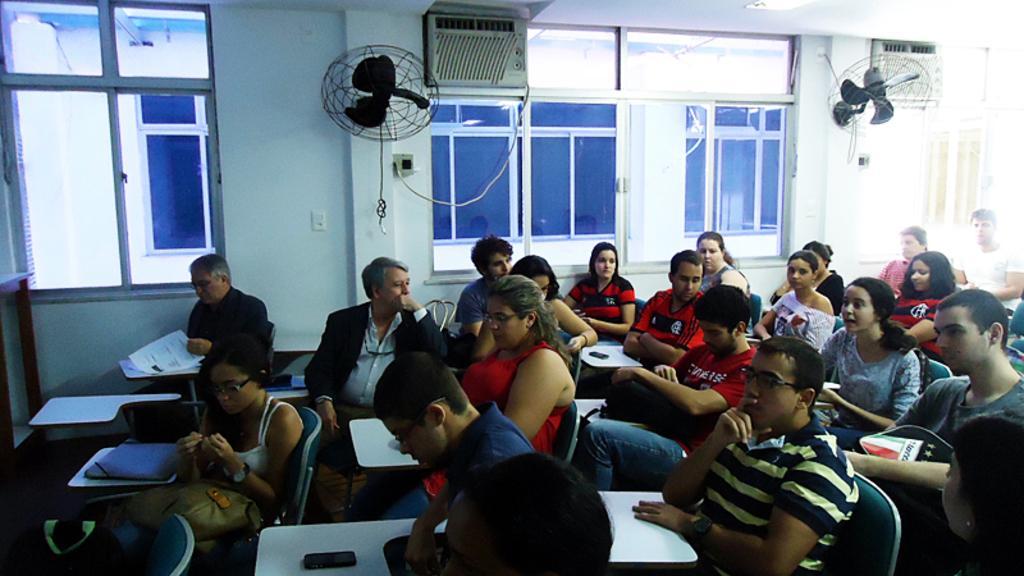Could you give a brief overview of what you see in this image? In this image in the center there are some people who are sitting on chairs, and there are some desks. On the desks there are some papers and pens, and in the background there are glass windows and a wall. On the wall there are two fans and on the top of the image there is one projector. 